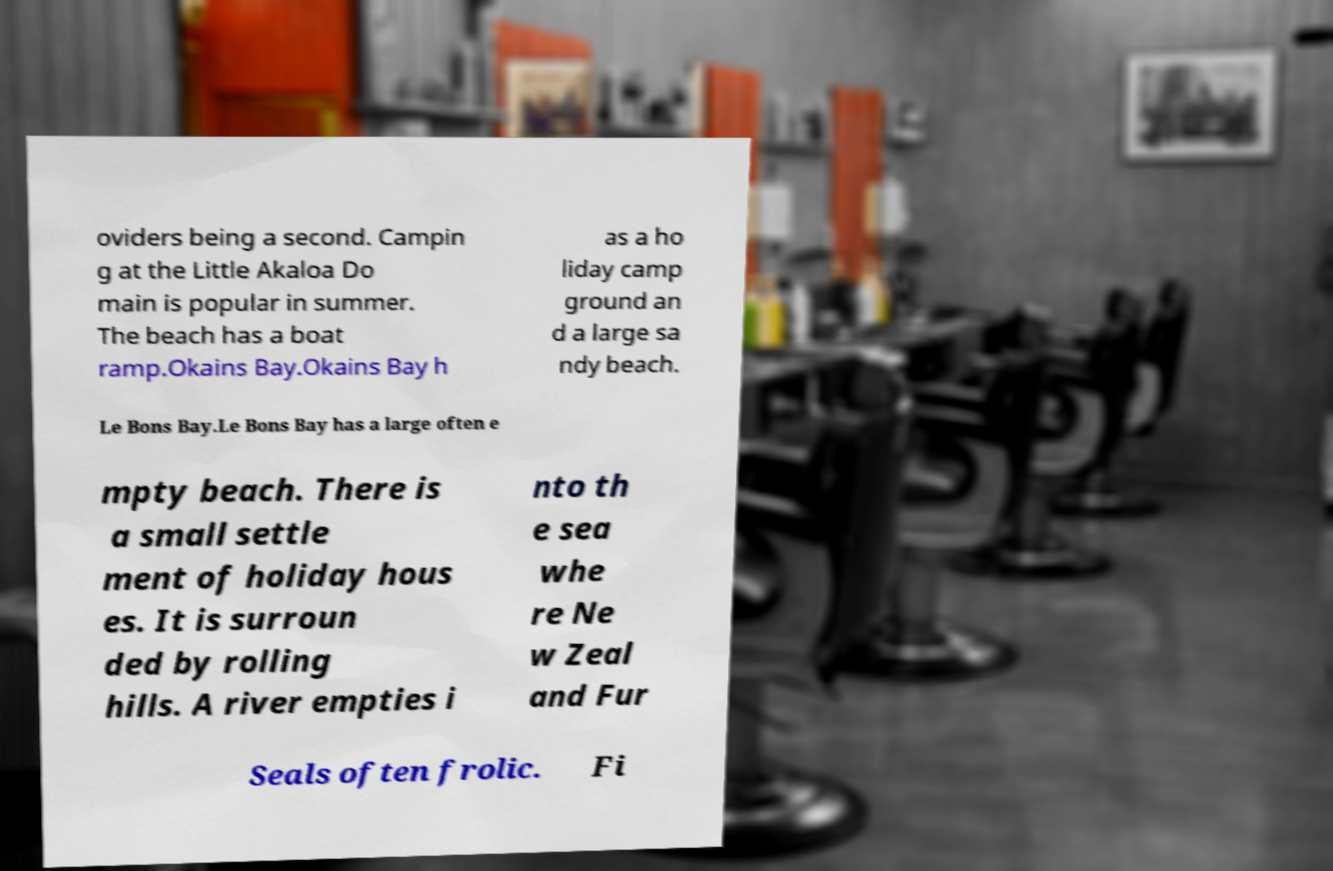Can you accurately transcribe the text from the provided image for me? oviders being a second. Campin g at the Little Akaloa Do main is popular in summer. The beach has a boat ramp.Okains Bay.Okains Bay h as a ho liday camp ground an d a large sa ndy beach. Le Bons Bay.Le Bons Bay has a large often e mpty beach. There is a small settle ment of holiday hous es. It is surroun ded by rolling hills. A river empties i nto th e sea whe re Ne w Zeal and Fur Seals often frolic. Fi 